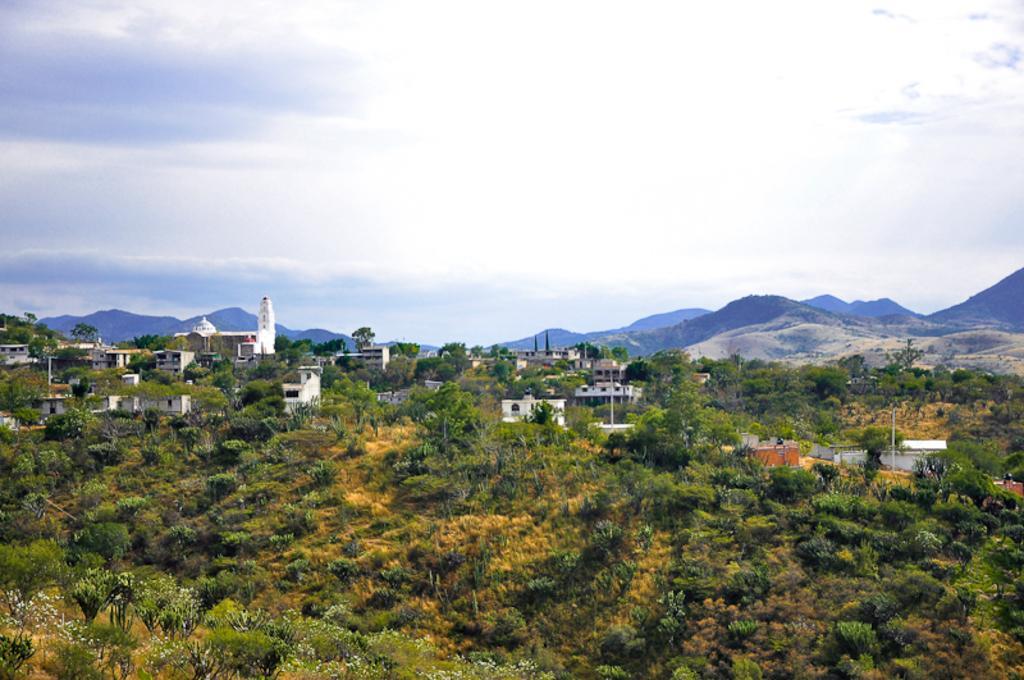How would you summarize this image in a sentence or two? In this image we can see many buildings. At the bottom there are trees. In the background there are hills and sky. 